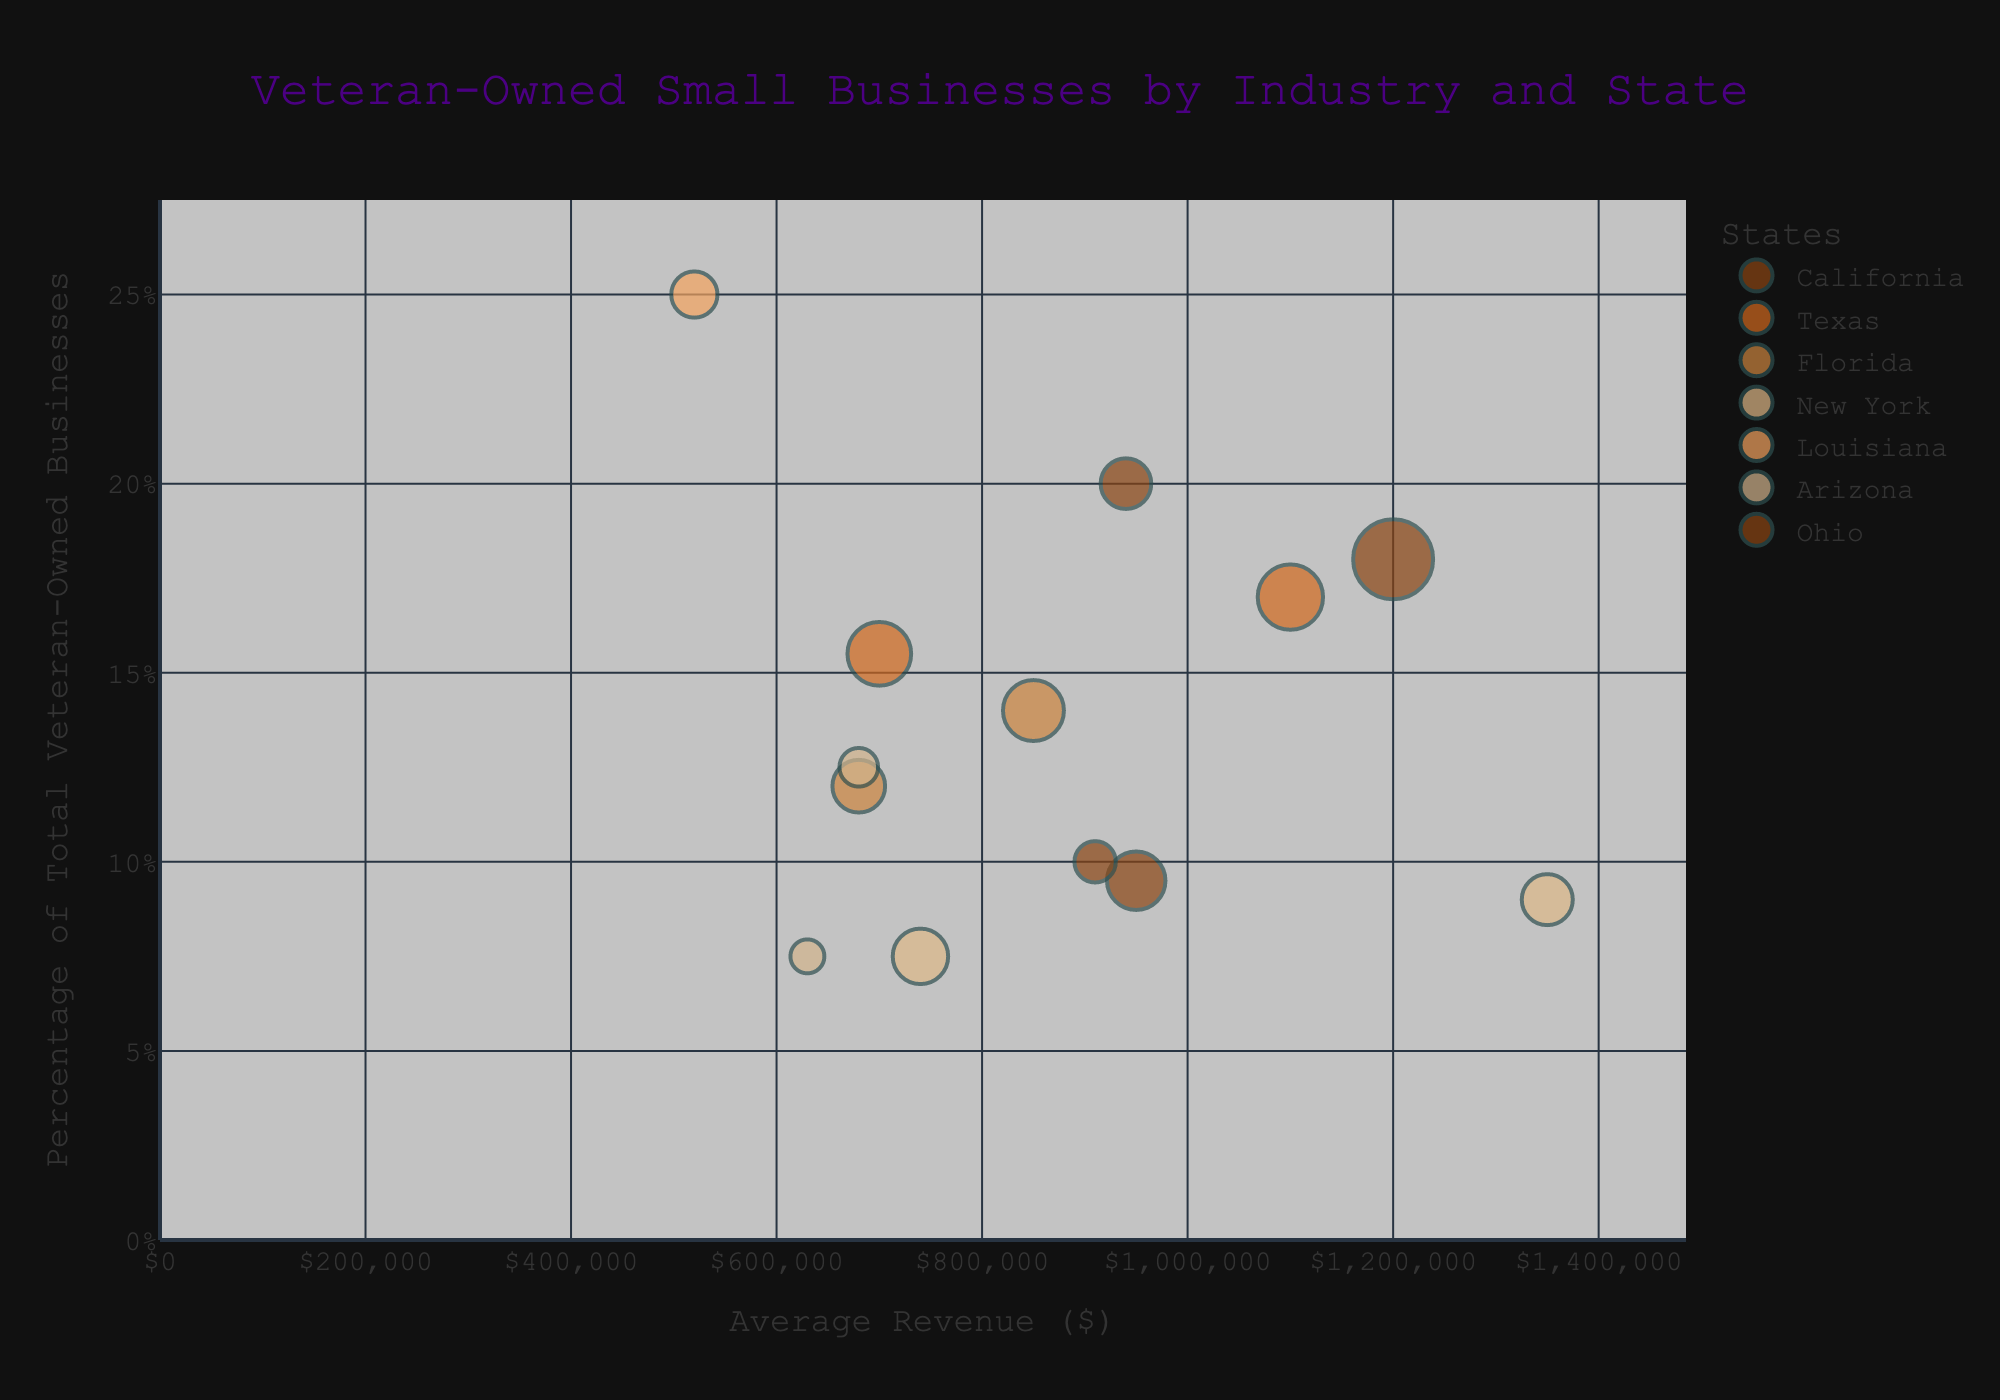What's the title of the figure? The title is displayed prominently at the top of the figure. It reads "Veteran-Owned Small Businesses by Industry and State".
Answer: Veteran-Owned Small Businesses by Industry and State What's on the x-axis of the figure? The x-axis title is "Average Revenue ($)". It shows the average revenue for each industry in various states.
Answer: Average Revenue ($) Which state has the largest bubble in the chart? The size of the bubble represents the number of businesses. The largest bubble belongs to California with 150 businesses in the Construction industry.
Answer: California What industry in Louisiana has Veteran-owned businesses with the highest average revenue? Look for Louisiana on the chart and identify the industry bubble with the highest x-axis value. In this case, it is the Construction industry with an average revenue of $520,000.
Answer: Construction How does the percentage of veteran-owned businesses in Ohio's Manufacturing industry compare to Louisiana's Construction industry? The y-axis shows the percentage. Ohio's Manufacturing is at 20%, while Louisiana's Construction is at 25%. Louisiana's percentage is higher.
Answer: Louisiana's is higher Which state has the smallest bubble? The bubble size indicates the number of businesses. The smallest bubble belongs to Arizona in the Education Services industry with 27 businesses.
Answer: Arizona Compare the average revenue between New York's Finance and Insurance industry and Ohio's Manufacturing industry. The x-axis shows the average revenue. New York's Finance and Insurance industry has an average revenue of $1,350,000, while Ohio's Manufacturing industry has $940,000. New York's value is higher.
Answer: New York's is higher What industry in Texas has the highest percentage of veteran-owned businesses? Look for Texas and check the y-axis values. Construction is at 17%, which is higher than Retail at 15.5%.
Answer: Construction Which state has more industries in the chart, California or Arizona, and how many does each state have? Count the number of bubbles for each state. California has two industries (Construction and Healthcare), and Arizona has two (Real Estate and Education Services). They have the same number.
Answer: Both have two What percentage of veteran-owned businesses in Florida are in the Accommodation and Food Services industry? Check the y-axis for Florida's Accommodation and Food Services bubble. It shows 14%.
Answer: 14% 